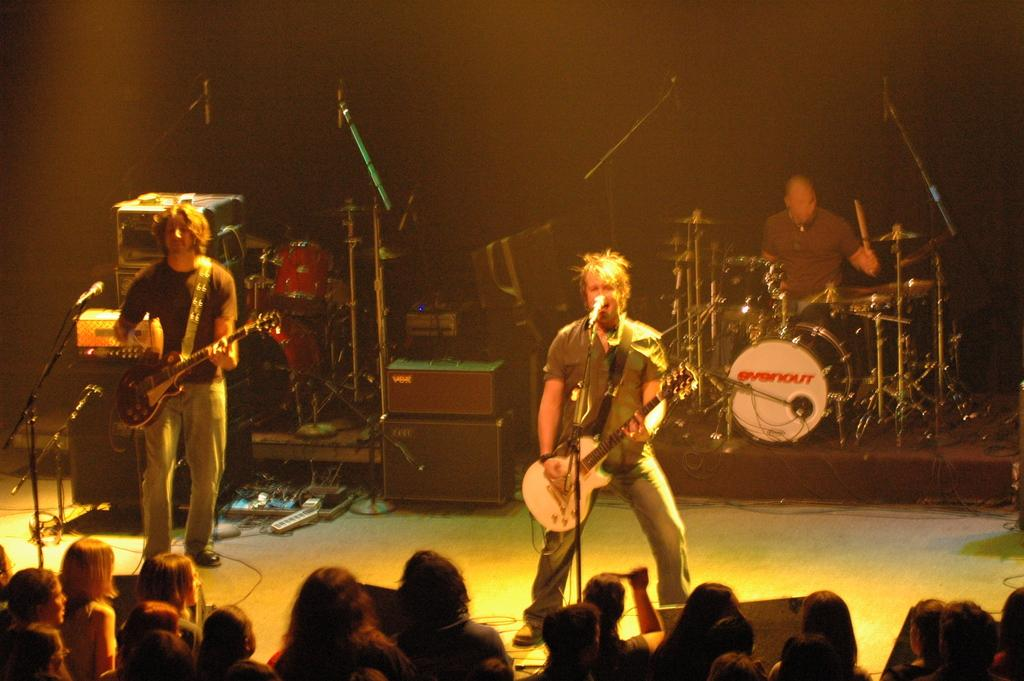How many men are playing musical instruments in the image? There are three men in the image, and two of them are playing guitar. What is the third man playing in the image? The third man is playing drums. Where are the men performing in the image? The men are on a stage. What type of receipt can be seen on the drum set in the image? There is no receipt present in the image, as it features three men playing musical instruments on a stage. 